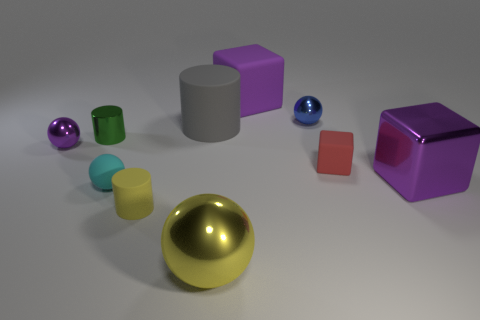Subtract all cylinders. How many objects are left? 7 Subtract 1 purple spheres. How many objects are left? 9 Subtract all small cyan matte balls. Subtract all small rubber cylinders. How many objects are left? 8 Add 8 large cylinders. How many large cylinders are left? 9 Add 3 small brown metal balls. How many small brown metal balls exist? 3 